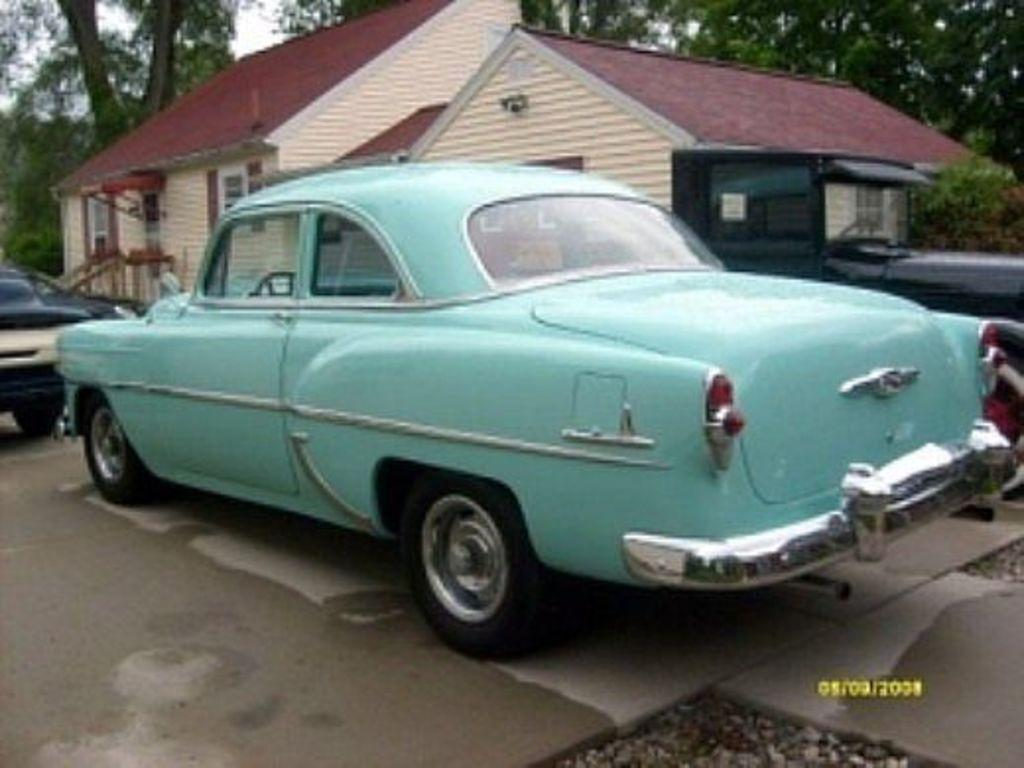What can be seen on the road in the image? There are cars on the road in the image. What type of structure is visible in the image? There is a house with windows in the image. What is in the background of the image? There are trees in the background of the image. Where is the watermark located in the image? The watermark is at the bottom right side of the image. What type of chalk is being used by the doctor near the volcano in the image? There is no chalk, doctor, or volcano present in the image. 